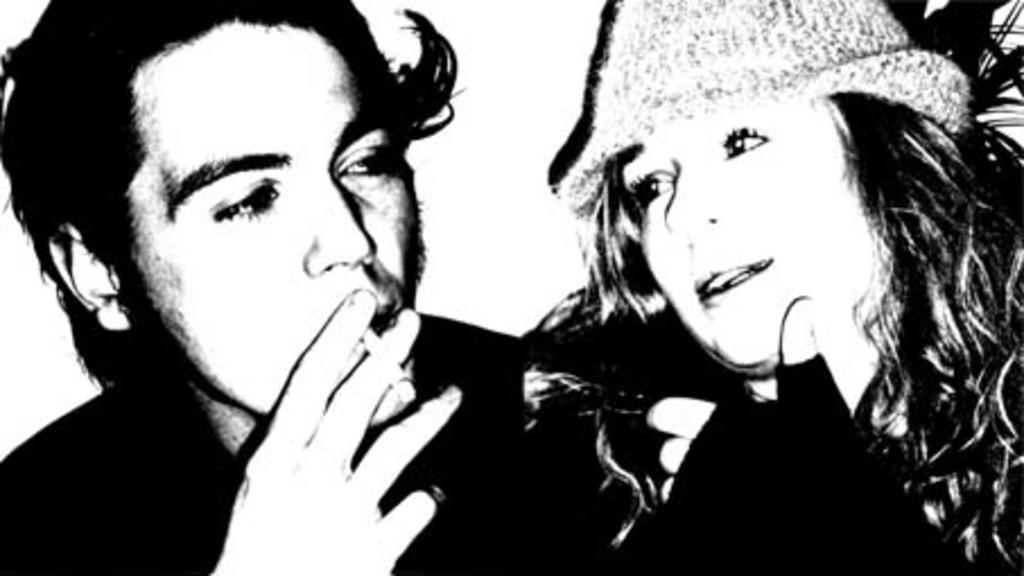Could you give a brief overview of what you see in this image? This is an edited image, we can see there are two people and a person is holding a cigarette. 